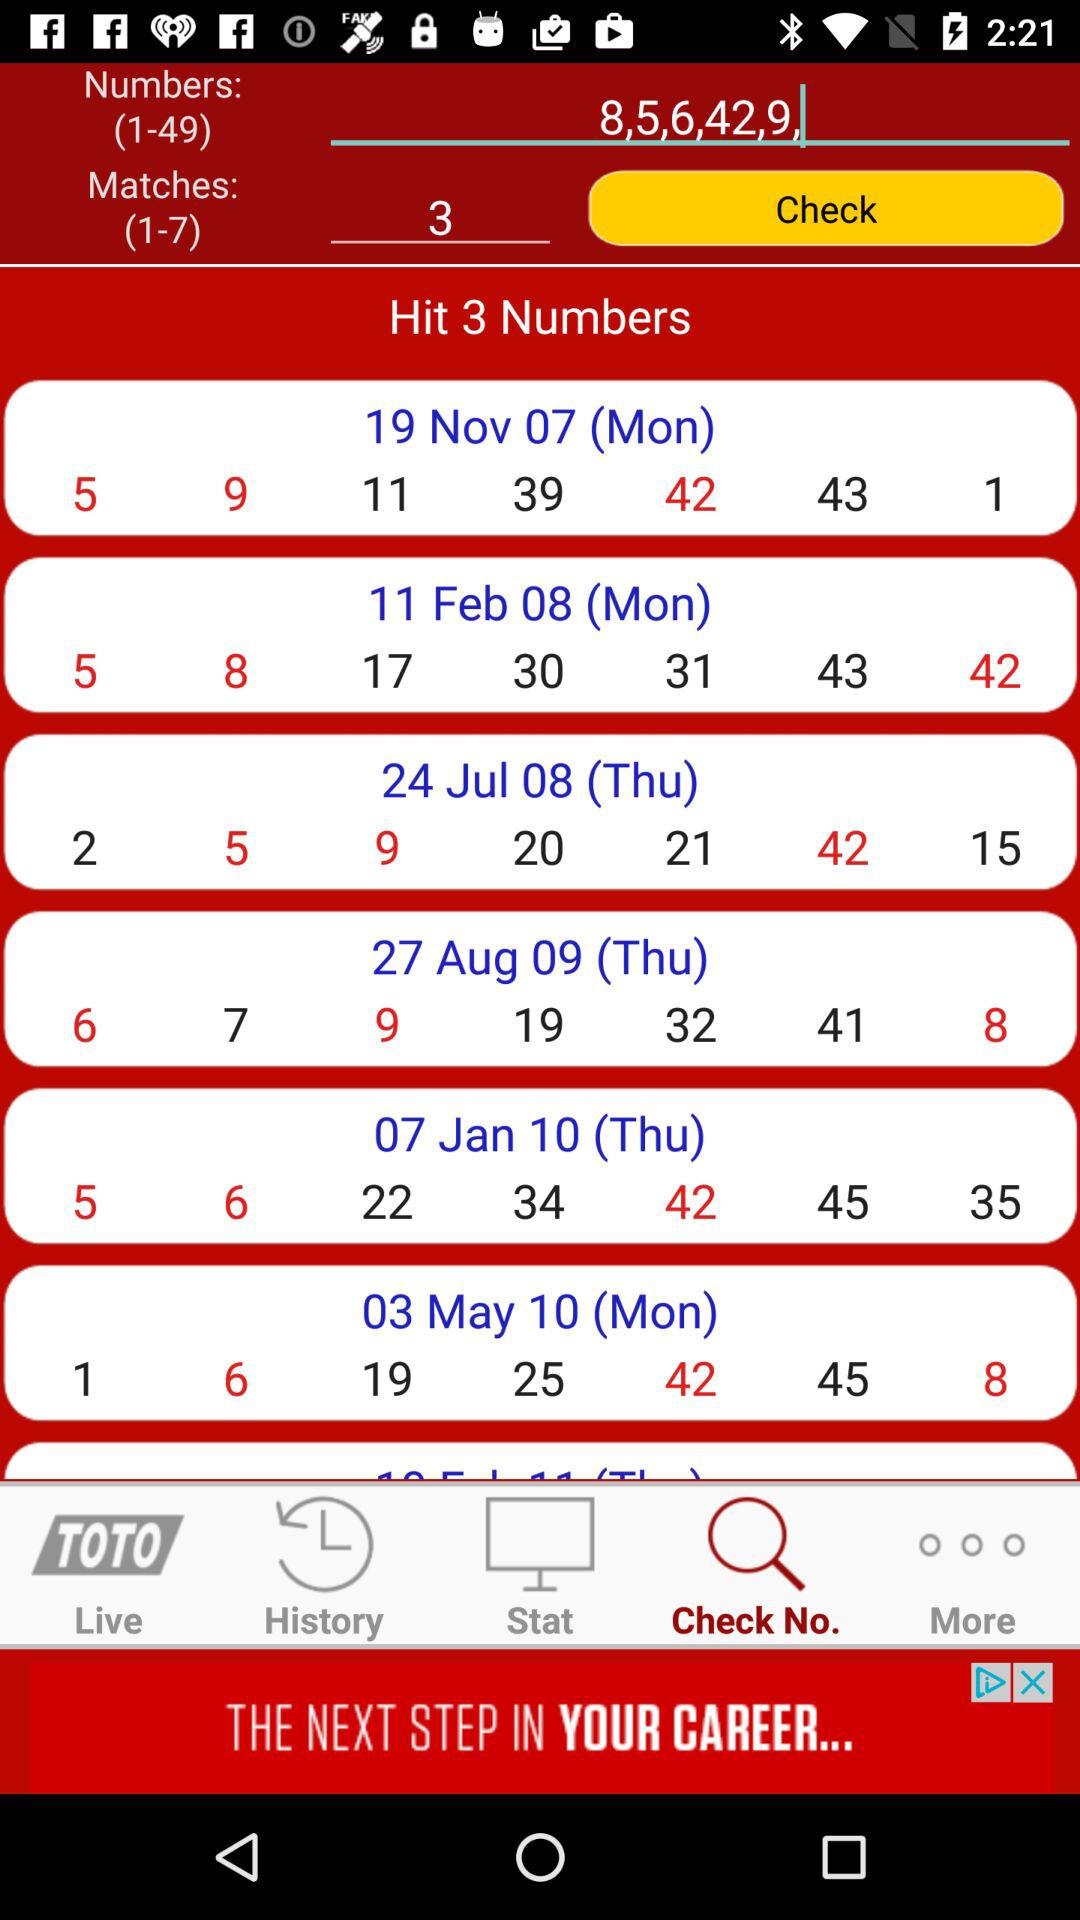How many total matches? The total matches are 3. 